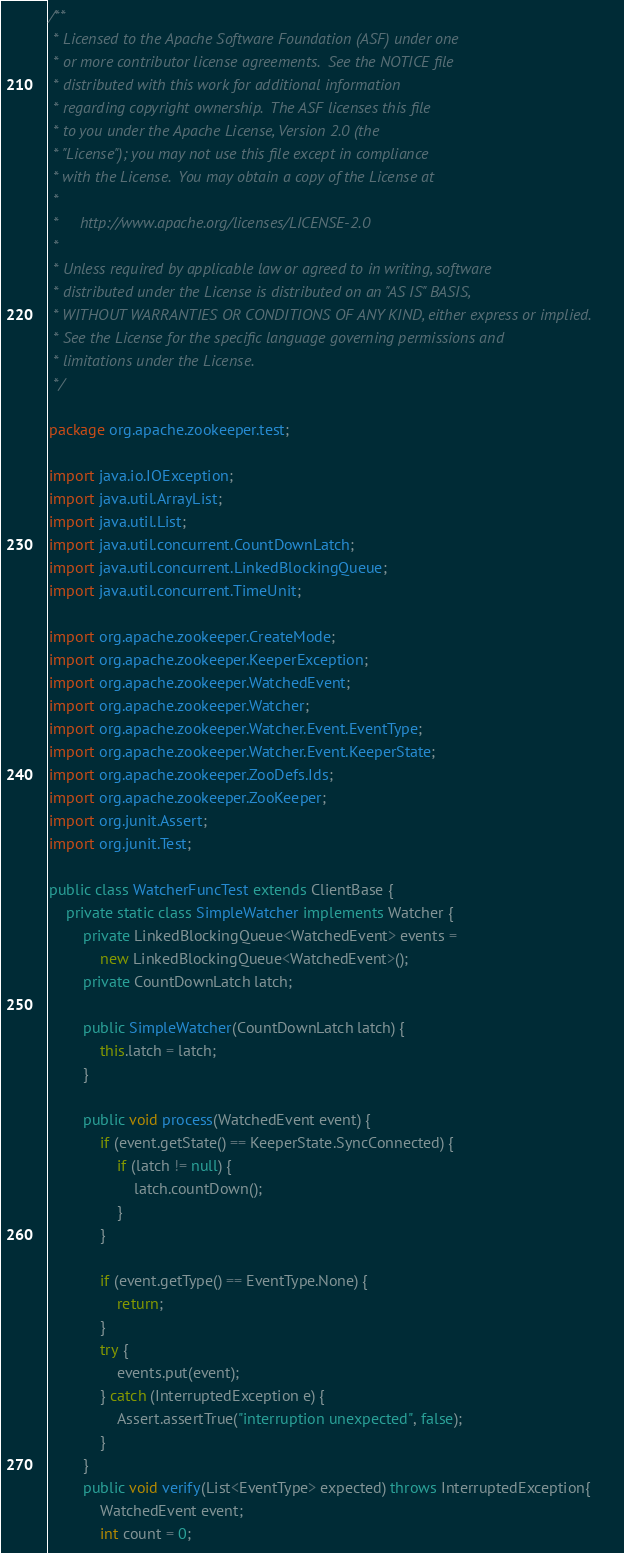<code> <loc_0><loc_0><loc_500><loc_500><_Java_>/**
 * Licensed to the Apache Software Foundation (ASF) under one
 * or more contributor license agreements.  See the NOTICE file
 * distributed with this work for additional information
 * regarding copyright ownership.  The ASF licenses this file
 * to you under the Apache License, Version 2.0 (the
 * "License"); you may not use this file except in compliance
 * with the License.  You may obtain a copy of the License at
 *
 *     http://www.apache.org/licenses/LICENSE-2.0
 *
 * Unless required by applicable law or agreed to in writing, software
 * distributed under the License is distributed on an "AS IS" BASIS,
 * WITHOUT WARRANTIES OR CONDITIONS OF ANY KIND, either express or implied.
 * See the License for the specific language governing permissions and
 * limitations under the License.
 */

package org.apache.zookeeper.test;

import java.io.IOException;
import java.util.ArrayList;
import java.util.List;
import java.util.concurrent.CountDownLatch;
import java.util.concurrent.LinkedBlockingQueue;
import java.util.concurrent.TimeUnit;

import org.apache.zookeeper.CreateMode;
import org.apache.zookeeper.KeeperException;
import org.apache.zookeeper.WatchedEvent;
import org.apache.zookeeper.Watcher;
import org.apache.zookeeper.Watcher.Event.EventType;
import org.apache.zookeeper.Watcher.Event.KeeperState;
import org.apache.zookeeper.ZooDefs.Ids;
import org.apache.zookeeper.ZooKeeper;
import org.junit.Assert;
import org.junit.Test;

public class WatcherFuncTest extends ClientBase {
    private static class SimpleWatcher implements Watcher {
        private LinkedBlockingQueue<WatchedEvent> events =
            new LinkedBlockingQueue<WatchedEvent>();
        private CountDownLatch latch;

        public SimpleWatcher(CountDownLatch latch) {
            this.latch = latch;
        }

        public void process(WatchedEvent event) {
            if (event.getState() == KeeperState.SyncConnected) {
                if (latch != null) {
                    latch.countDown();
                }
            }

            if (event.getType() == EventType.None) {
                return;
            }
            try {
                events.put(event);
            } catch (InterruptedException e) {
                Assert.assertTrue("interruption unexpected", false);
            }
        }
        public void verify(List<EventType> expected) throws InterruptedException{
            WatchedEvent event;
            int count = 0;</code> 